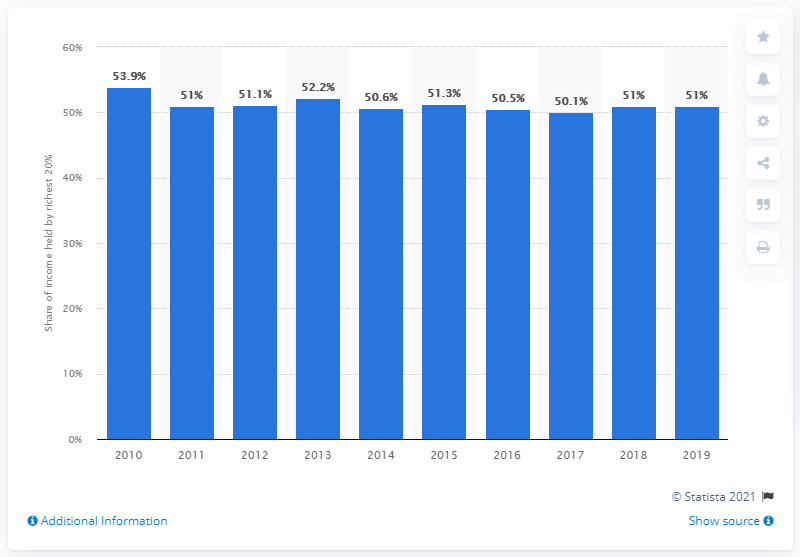Mention a couple of crucial points in this snapshot. According to data from 2019, the richest 20 percent of Ecuador's population held 51 percent of the country's income. 